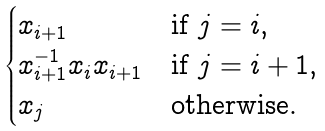Convert formula to latex. <formula><loc_0><loc_0><loc_500><loc_500>\begin{cases} x _ { i + 1 } & \text {if } j = i , \\ x _ { i + 1 } ^ { - 1 } x _ { i } x _ { i + 1 } & \text {if } j = i + 1 , \\ x _ { j } & \text {otherwise.} \end{cases}</formula> 